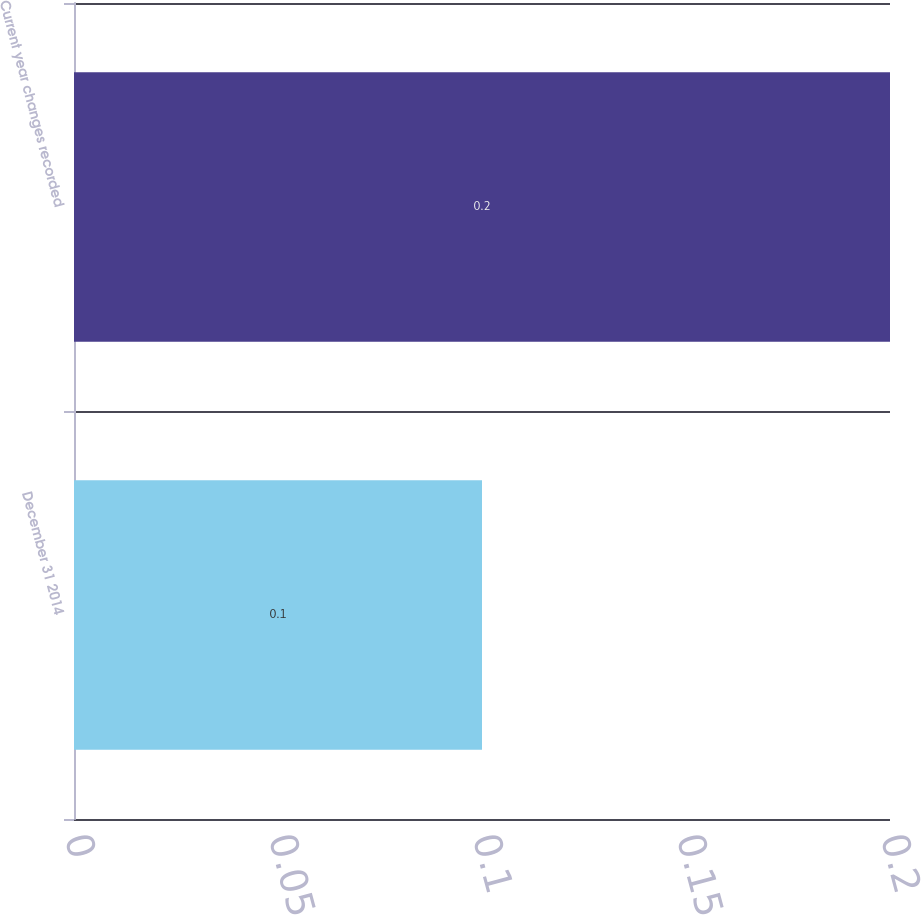Convert chart to OTSL. <chart><loc_0><loc_0><loc_500><loc_500><bar_chart><fcel>December 31 2014<fcel>Current year changes recorded<nl><fcel>0.1<fcel>0.2<nl></chart> 